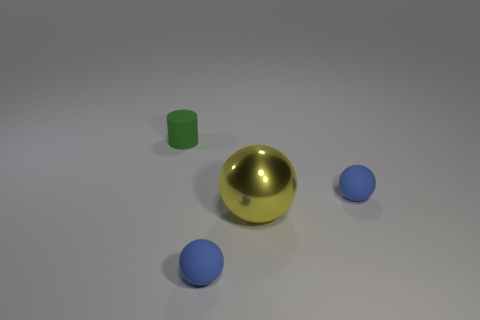Subtract all big balls. How many balls are left? 2 Subtract all red cubes. How many blue balls are left? 2 Subtract 1 balls. How many balls are left? 2 Add 2 small cylinders. How many objects exist? 6 Subtract all cylinders. How many objects are left? 3 Subtract all big cyan matte cylinders. Subtract all large metallic spheres. How many objects are left? 3 Add 1 yellow balls. How many yellow balls are left? 2 Add 2 green things. How many green things exist? 3 Subtract 0 red cylinders. How many objects are left? 4 